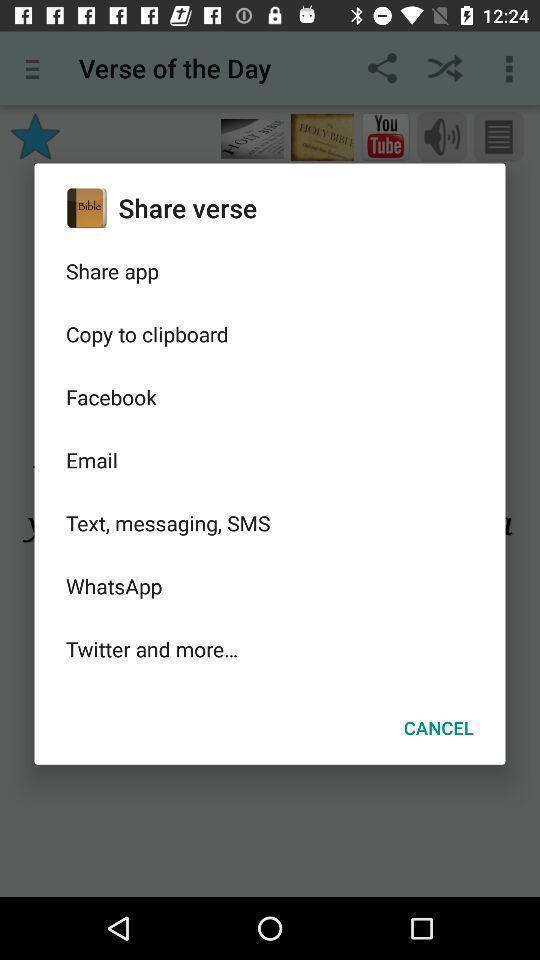Describe the visual elements of this screenshot. Pop-up showing options in an religion related app. 